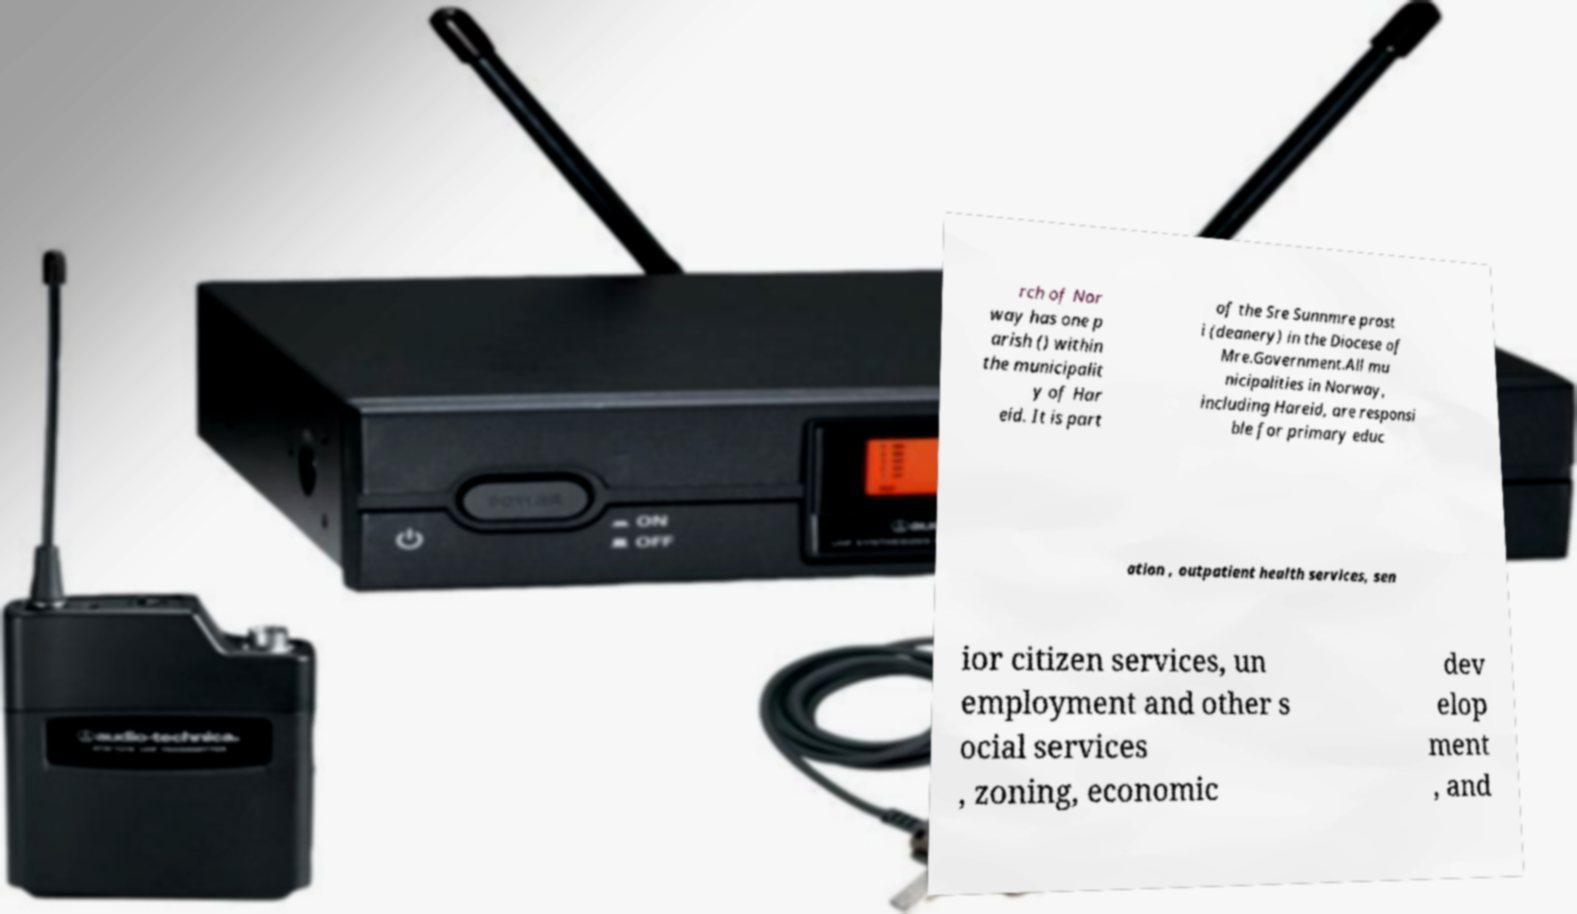For documentation purposes, I need the text within this image transcribed. Could you provide that? rch of Nor way has one p arish () within the municipalit y of Har eid. It is part of the Sre Sunnmre prost i (deanery) in the Diocese of Mre.Government.All mu nicipalities in Norway, including Hareid, are responsi ble for primary educ ation , outpatient health services, sen ior citizen services, un employment and other s ocial services , zoning, economic dev elop ment , and 